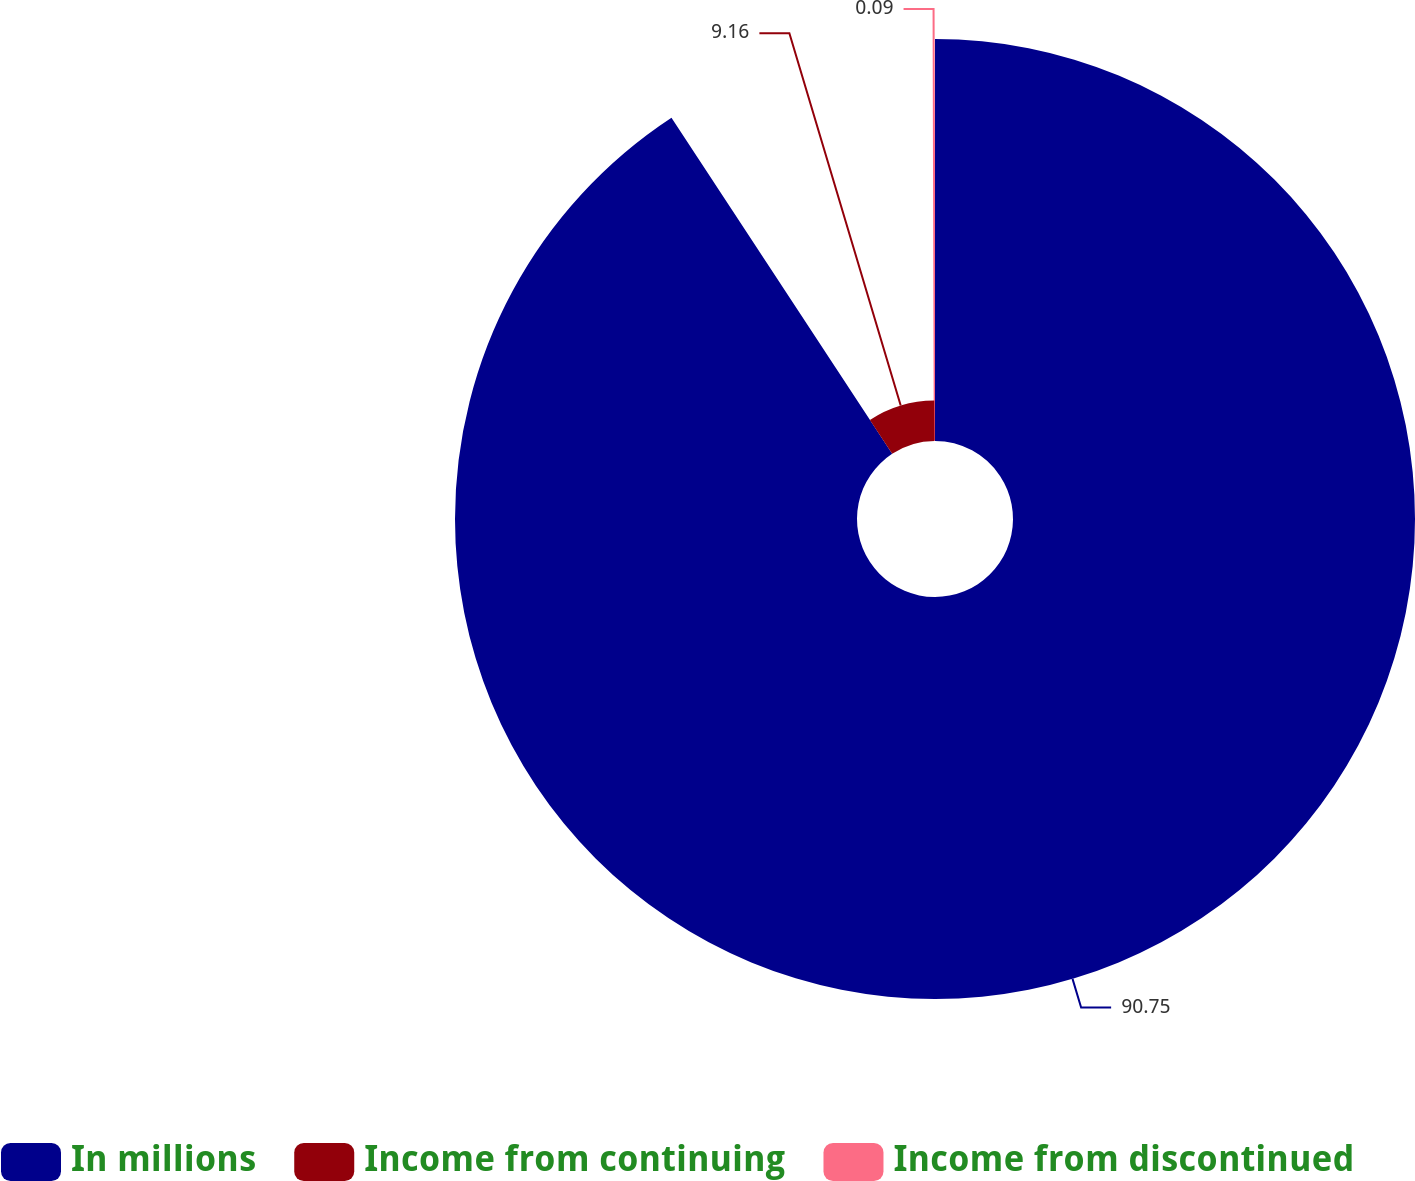Convert chart to OTSL. <chart><loc_0><loc_0><loc_500><loc_500><pie_chart><fcel>In millions<fcel>Income from continuing<fcel>Income from discontinued<nl><fcel>90.75%<fcel>9.16%<fcel>0.09%<nl></chart> 